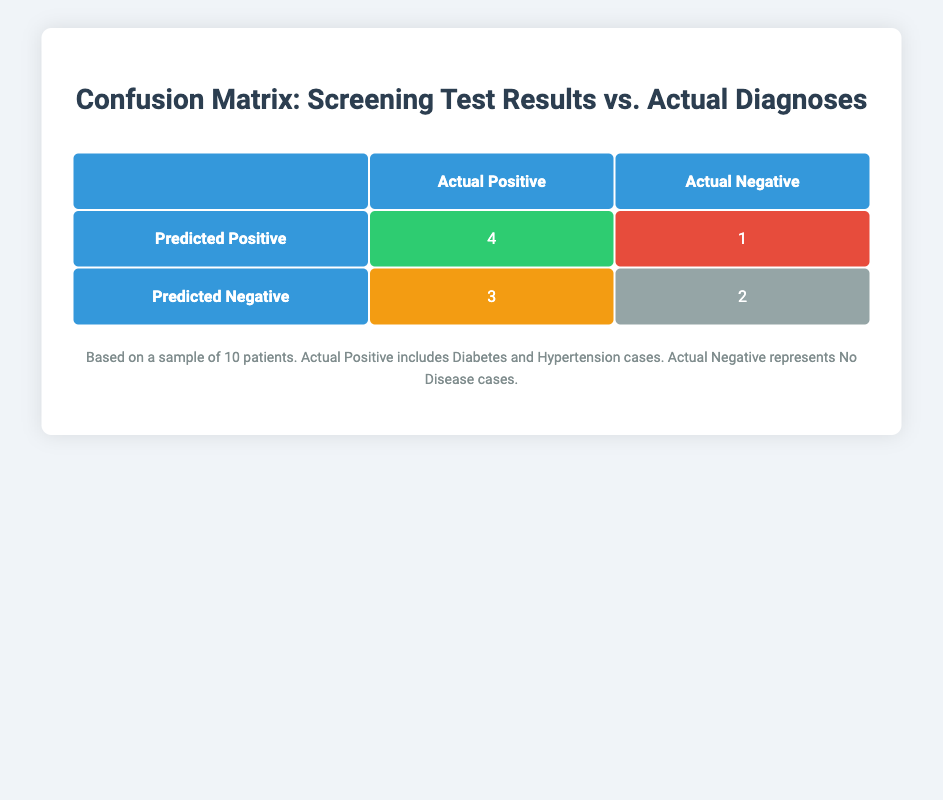What is the number of true positives from the screening tests? The table shows that there are 4 cases identified as true positives, represented in the cell where "Predicted Positive" intersects with "Actual Positive."
Answer: 4 How many patients were incorrectly diagnosed as having a disease when they did not? In the table, the cell denoting false positives (Predicted Positive, Actual Negative) shows 1 patient. This is the count of patients who tested positive but were actually disease-free.
Answer: 1 What is the total number of patients with actual negative diagnoses? The actual negative diagnoses include both "No Disease" patients. In the table, there are 2 cases marked as true negatives.
Answer: 2 If we add the true negatives and the false positives together, what total do we get? To find the sum, we take the true negatives (2) and the false positives (1). Therefore, adding them gives us 2 + 1 = 3.
Answer: 3 Is it true that the screening test resulted in more true positives than false negatives? To verify, we look at the true positives (4) and false negatives (3) in the table. Since 4 is greater than 3, the statement is true.
Answer: Yes How many patients did not have diabetes but tested negative? From the data, the patients who did not have diabetes and tested negative are two patients with the "No Disease" diagnosis (Patient_ID 005 and 007).
Answer: 2 What percentage of the actual positive diagnoses were correctly identified as positive by the screening test? The total number of actual positive diagnoses is 4 (Diabetes) + 3 (Hypertension) = 7. The true positives are 4. To get the percentage, we use (4/7) * 100 = 57.14%.
Answer: 57.14% What is the ratio of false negatives to total actual positives? The total actual positive diagnoses are 7, and the number of false negatives (3) represents those who were incorrectly classified. To find the ratio, we divide false negatives by actual positives: 3:7.
Answer: 3:7 How many patients tested negative when they actually had diabetes? Upon examining the table, one patient (Patient_ID 008) tested negative but had diabetes, making the count 1.
Answer: 1 